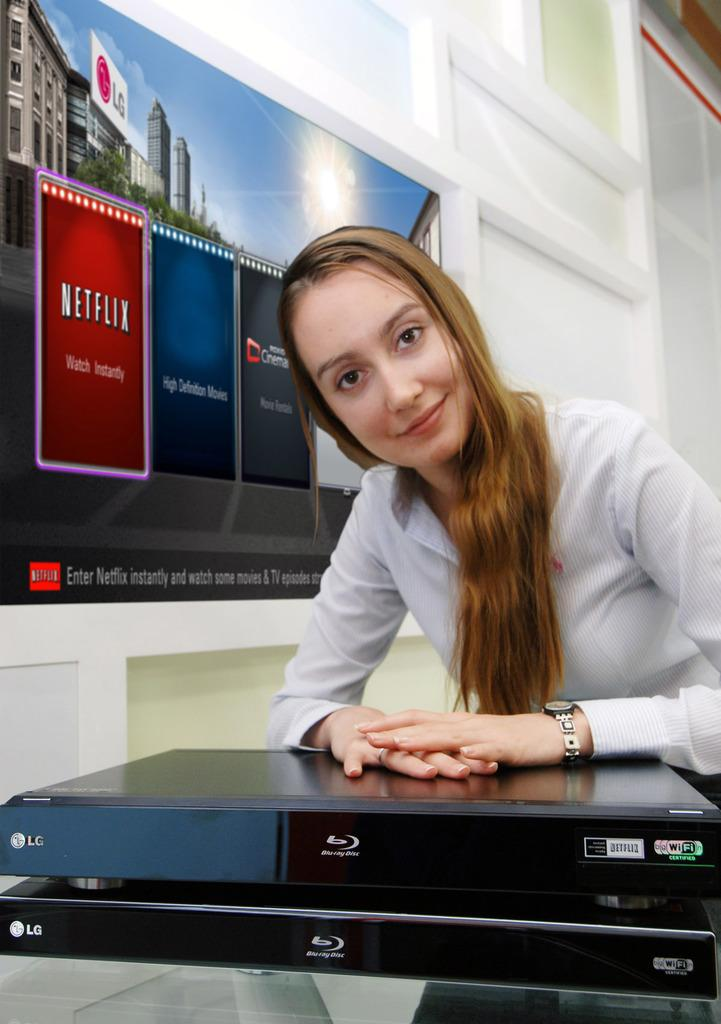<image>
Write a terse but informative summary of the picture. a lady next to a sign that says Netflix 